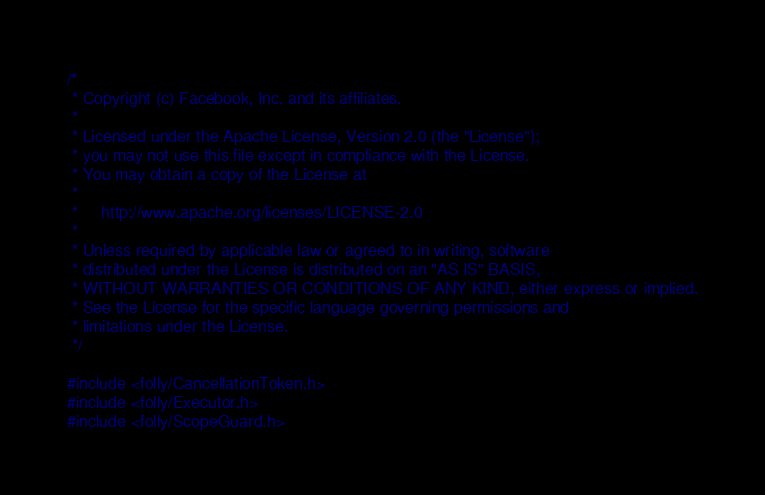<code> <loc_0><loc_0><loc_500><loc_500><_C_>/*
 * Copyright (c) Facebook, Inc. and its affiliates.
 *
 * Licensed under the Apache License, Version 2.0 (the "License");
 * you may not use this file except in compliance with the License.
 * You may obtain a copy of the License at
 *
 *     http://www.apache.org/licenses/LICENSE-2.0
 *
 * Unless required by applicable law or agreed to in writing, software
 * distributed under the License is distributed on an "AS IS" BASIS,
 * WITHOUT WARRANTIES OR CONDITIONS OF ANY KIND, either express or implied.
 * See the License for the specific language governing permissions and
 * limitations under the License.
 */

#include <folly/CancellationToken.h>
#include <folly/Executor.h>
#include <folly/ScopeGuard.h></code> 